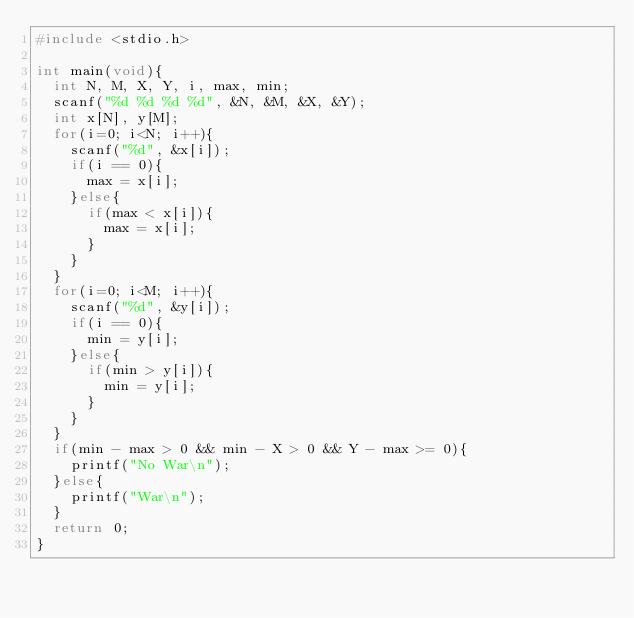<code> <loc_0><loc_0><loc_500><loc_500><_C_>#include <stdio.h>

int main(void){
  int N, M, X, Y, i, max, min;
  scanf("%d %d %d %d", &N, &M, &X, &Y);
  int x[N], y[M];
  for(i=0; i<N; i++){
    scanf("%d", &x[i]);
    if(i == 0){
      max = x[i];
    }else{
      if(max < x[i]){
        max = x[i];
      }
    }
  }
  for(i=0; i<M; i++){
    scanf("%d", &y[i]);
    if(i == 0){
      min = y[i];
    }else{
      if(min > y[i]){
        min = y[i];
      }
    }
  }
  if(min - max > 0 && min - X > 0 && Y - max >= 0){
    printf("No War\n");
  }else{
    printf("War\n");
  }
  return 0;
}
</code> 